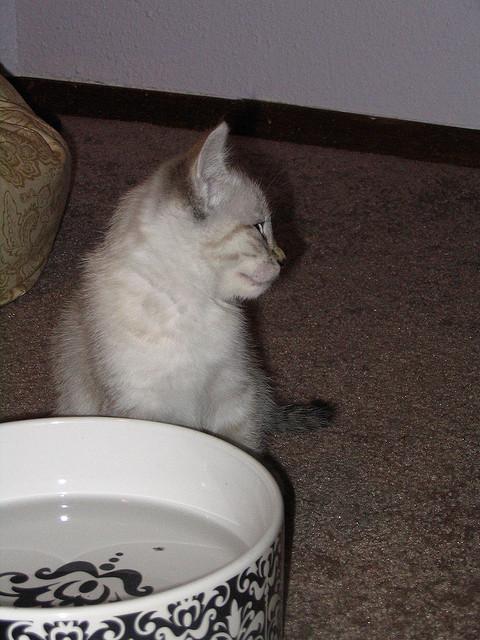How many bowls are pictured?
Give a very brief answer. 1. How many cars are parked?
Give a very brief answer. 0. 